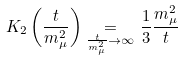<formula> <loc_0><loc_0><loc_500><loc_500>K _ { 2 } \left ( \frac { t } { m _ { \mu } ^ { 2 } } \right ) \underset { \frac { t } { m _ { \mu } ^ { 2 } } \rightarrow \infty } = \frac { 1 } { 3 } \frac { m _ { \mu } ^ { 2 } } { t }</formula> 